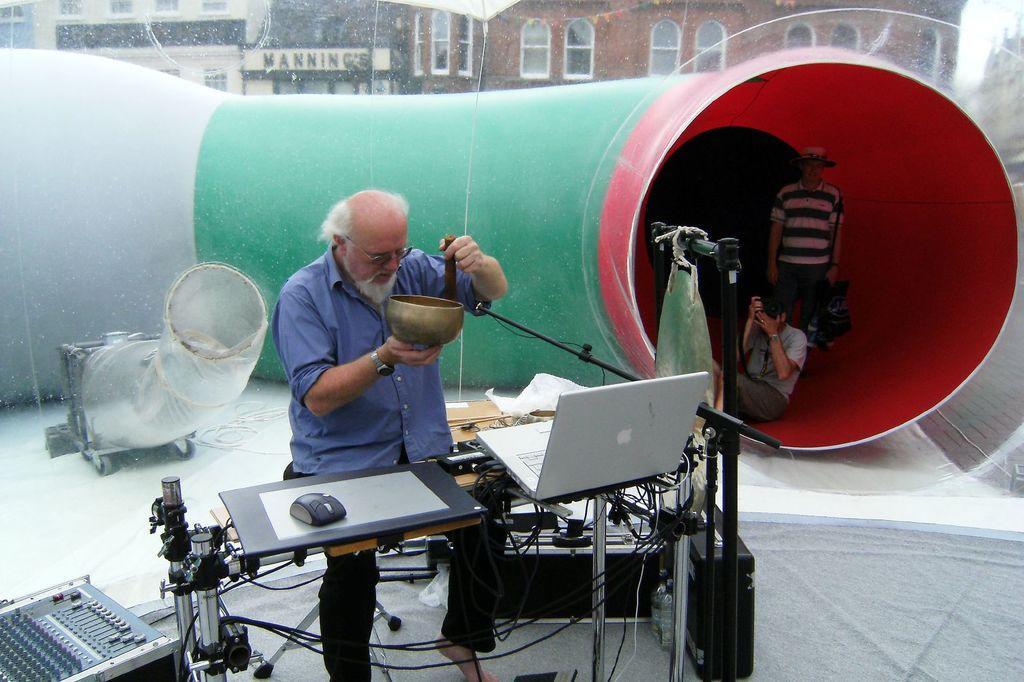Describe this image in one or two sentences. This image is clicked outside. There is a big pipe in the background. There are three persons in this image. In the middle, the person is wearing blue shirt and black pant. In front of him, there is laptop, mouse and stands. To the right, the man is sitting and holding the camera. In the background, there are buildings. 